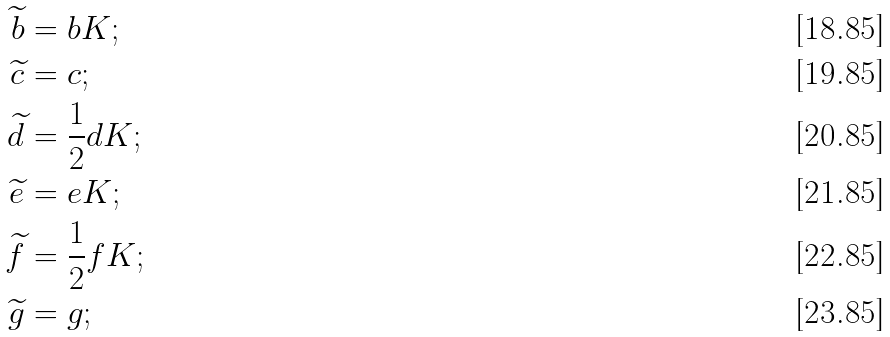<formula> <loc_0><loc_0><loc_500><loc_500>\widetilde { b } & = b K ; \\ \widetilde { c } & = c ; \\ \widetilde { d } & = \frac { 1 } { 2 } d K ; \\ \widetilde { e } & = e K ; \\ \widetilde { f } & = \frac { 1 } { 2 } f K ; \\ \widetilde { g } & = g ;</formula> 